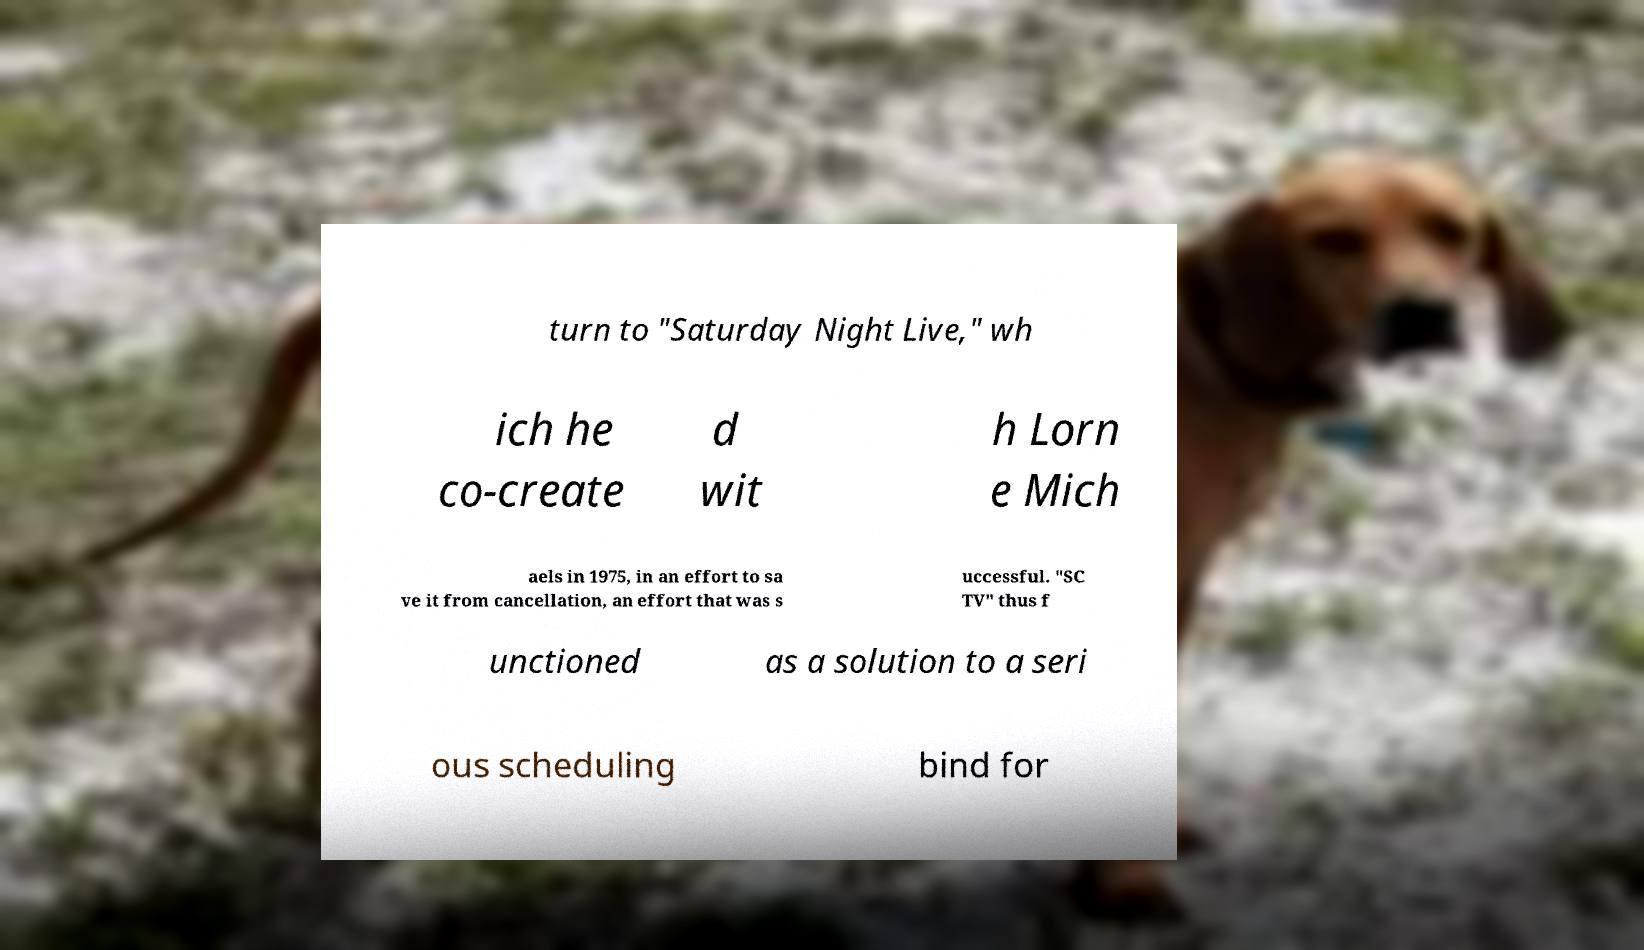For documentation purposes, I need the text within this image transcribed. Could you provide that? turn to "Saturday Night Live," wh ich he co-create d wit h Lorn e Mich aels in 1975, in an effort to sa ve it from cancellation, an effort that was s uccessful. "SC TV" thus f unctioned as a solution to a seri ous scheduling bind for 